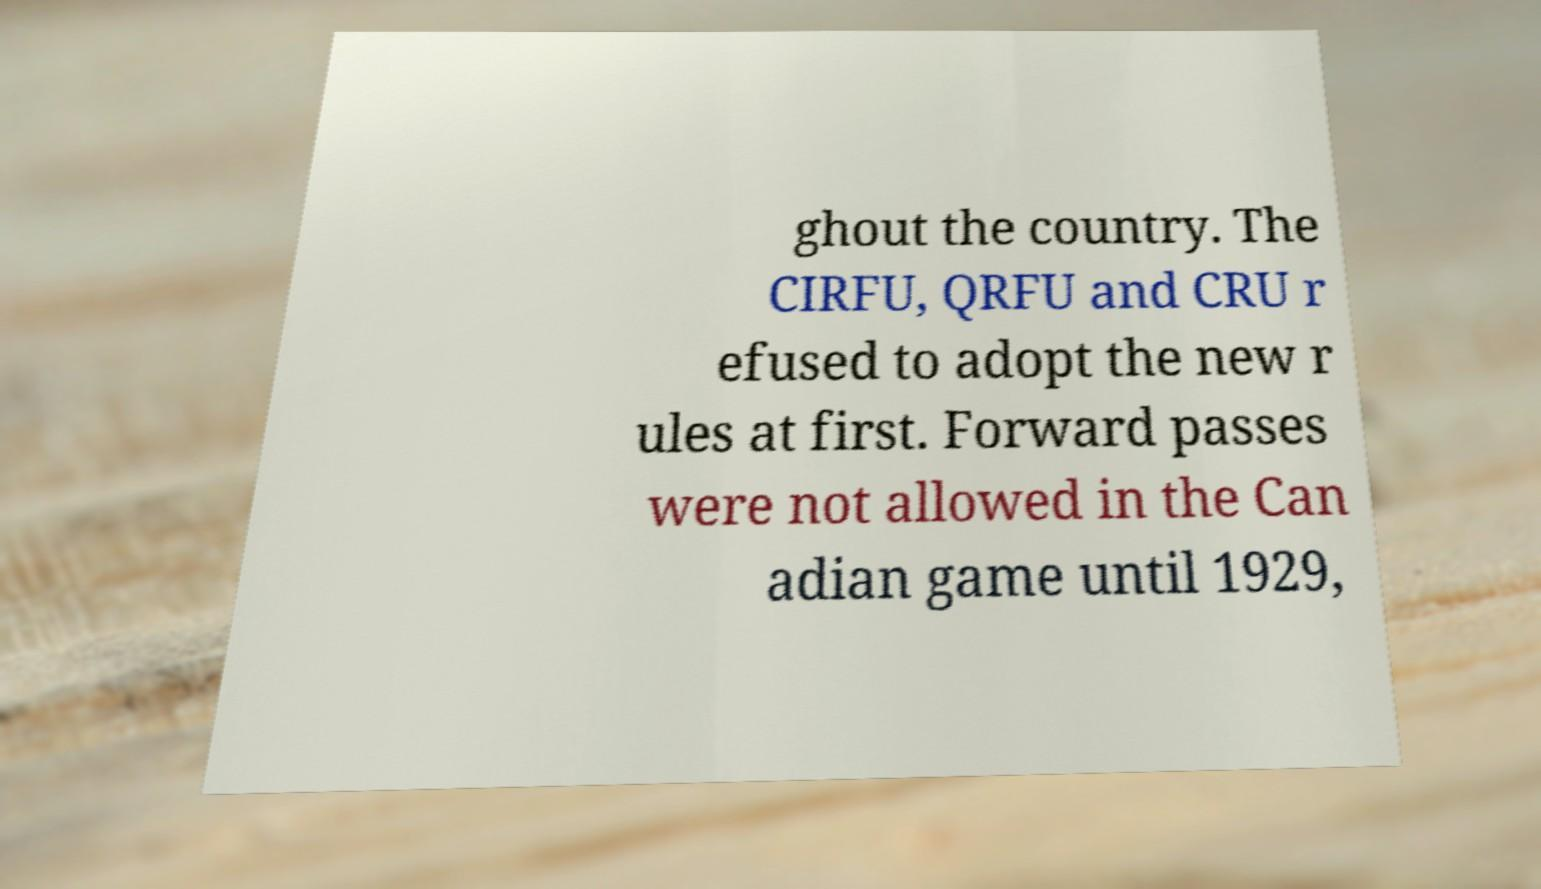What messages or text are displayed in this image? I need them in a readable, typed format. ghout the country. The CIRFU, QRFU and CRU r efused to adopt the new r ules at first. Forward passes were not allowed in the Can adian game until 1929, 